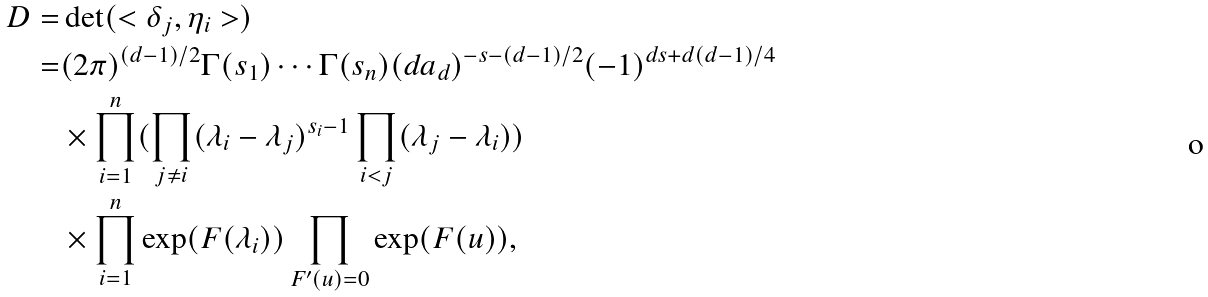<formula> <loc_0><loc_0><loc_500><loc_500>D = & \det ( < \delta _ { j } , \eta _ { i } > ) \\ = & ( 2 \pi ) ^ { ( d - 1 ) / 2 } \Gamma ( s _ { 1 } ) \cdots \Gamma ( s _ { n } ) ( d a _ { d } ) ^ { - s - ( d - 1 ) / 2 } ( - 1 ) ^ { d s + d ( d - 1 ) / 4 } \\ & \times \prod ^ { n } _ { i = 1 } ( \prod _ { j \ne i } ( \lambda _ { i } - \lambda _ { j } ) ^ { s _ { i } - 1 } \prod _ { i < j } ( \lambda _ { j } - \lambda _ { i } ) ) \\ & \times \prod ^ { n } _ { i = 1 } \exp ( F ( \lambda _ { i } ) ) \prod _ { F ^ { \prime } ( u ) = 0 } \exp ( F ( u ) ) ,</formula> 